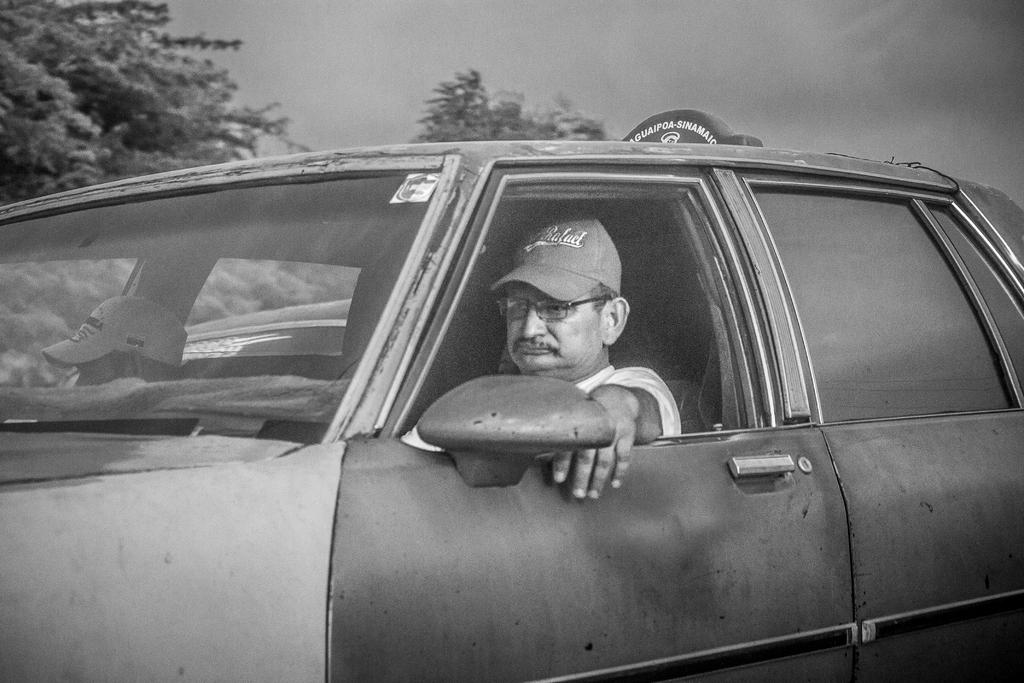What is the person in the image wearing? The person in the image is wearing a white dress. Where is the person sitting in the image? The person is sitting in a car. Who is sitting beside the person in the car? There is another person sitting beside the person in the car. What can be seen in the background of the image? There are trees in the background of the image. How would you describe the weather based on the image? The sky is cloudy in the image. What type of lumber is being used to construct the car in the image? There is no lumber visible in the image, as the car is a complete vehicle and not under construction. 